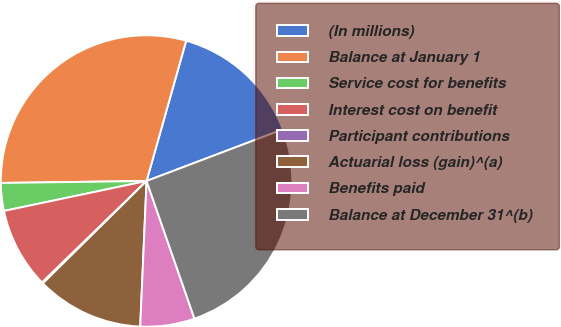Convert chart to OTSL. <chart><loc_0><loc_0><loc_500><loc_500><pie_chart><fcel>(In millions)<fcel>Balance at January 1<fcel>Service cost for benefits<fcel>Interest cost on benefit<fcel>Participant contributions<fcel>Actuarial loss (gain)^(a)<fcel>Benefits paid<fcel>Balance at December 31^(b)<nl><fcel>14.86%<fcel>29.59%<fcel>3.08%<fcel>8.97%<fcel>0.13%<fcel>11.91%<fcel>6.02%<fcel>25.43%<nl></chart> 